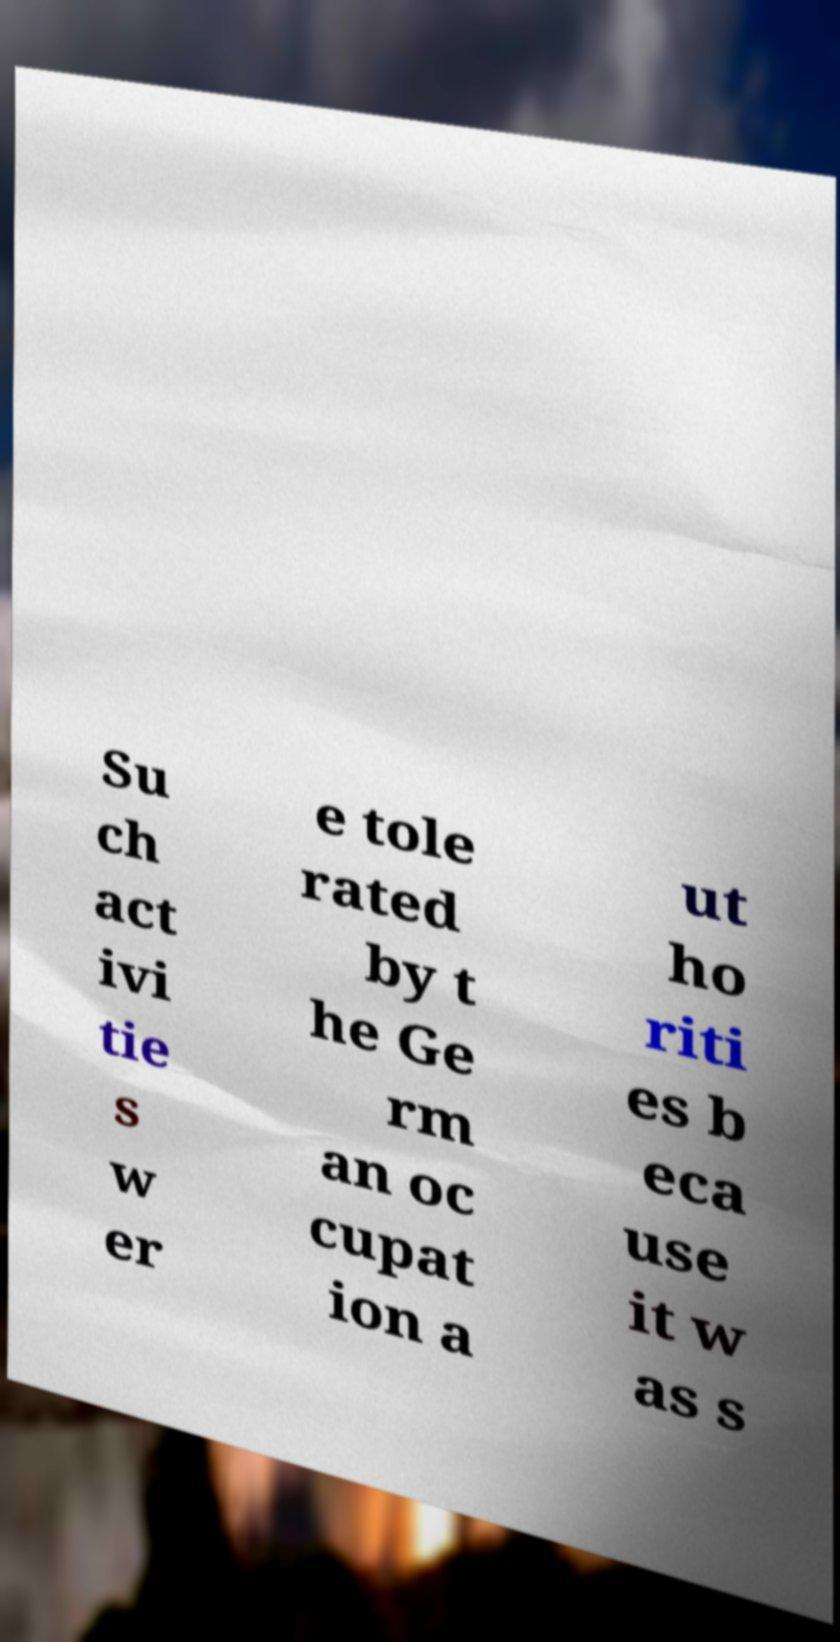Can you read and provide the text displayed in the image?This photo seems to have some interesting text. Can you extract and type it out for me? Su ch act ivi tie s w er e tole rated by t he Ge rm an oc cupat ion a ut ho riti es b eca use it w as s 